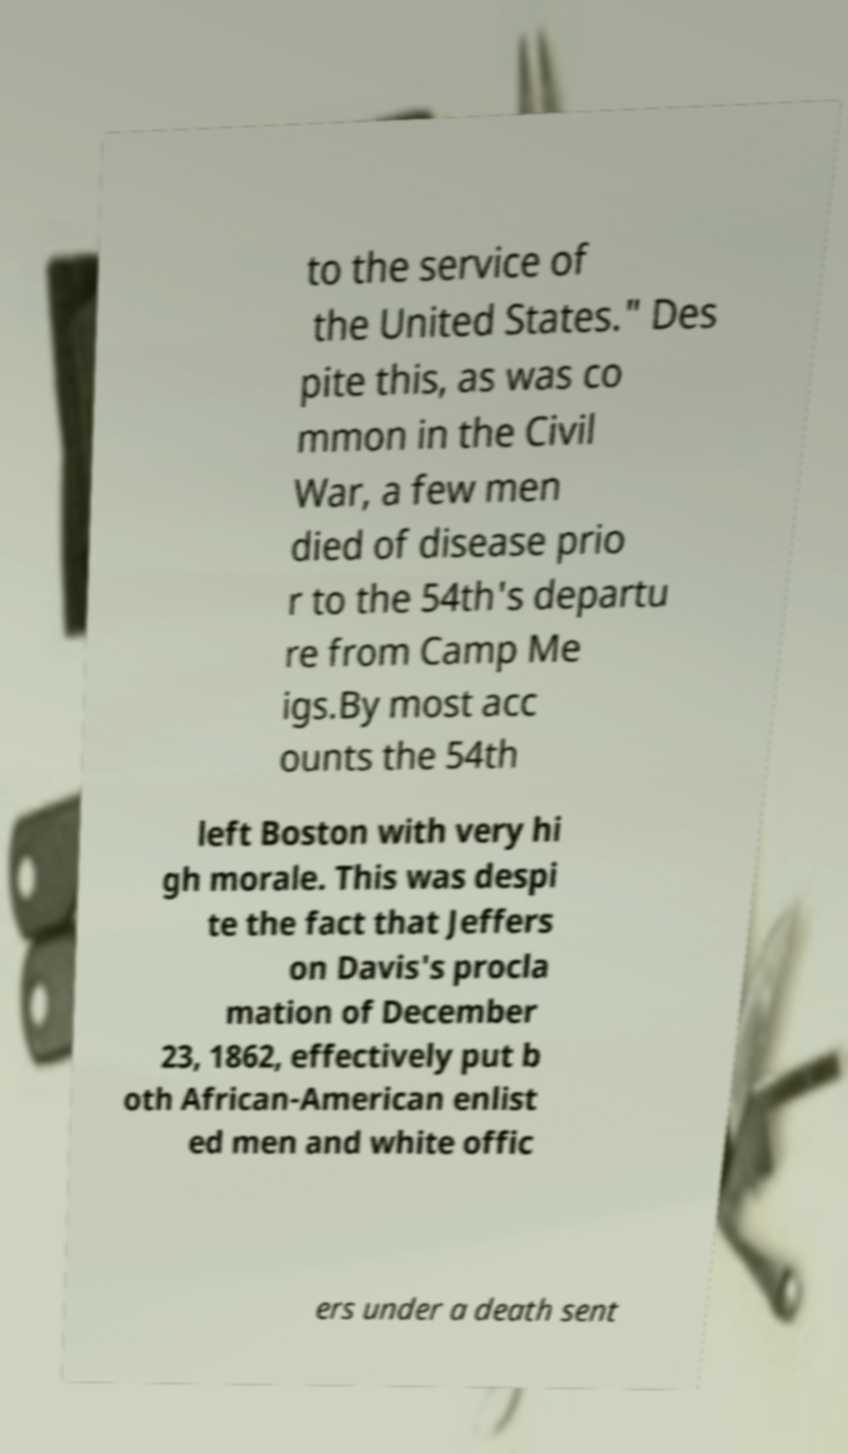For documentation purposes, I need the text within this image transcribed. Could you provide that? to the service of the United States." Des pite this, as was co mmon in the Civil War, a few men died of disease prio r to the 54th's departu re from Camp Me igs.By most acc ounts the 54th left Boston with very hi gh morale. This was despi te the fact that Jeffers on Davis's procla mation of December 23, 1862, effectively put b oth African-American enlist ed men and white offic ers under a death sent 